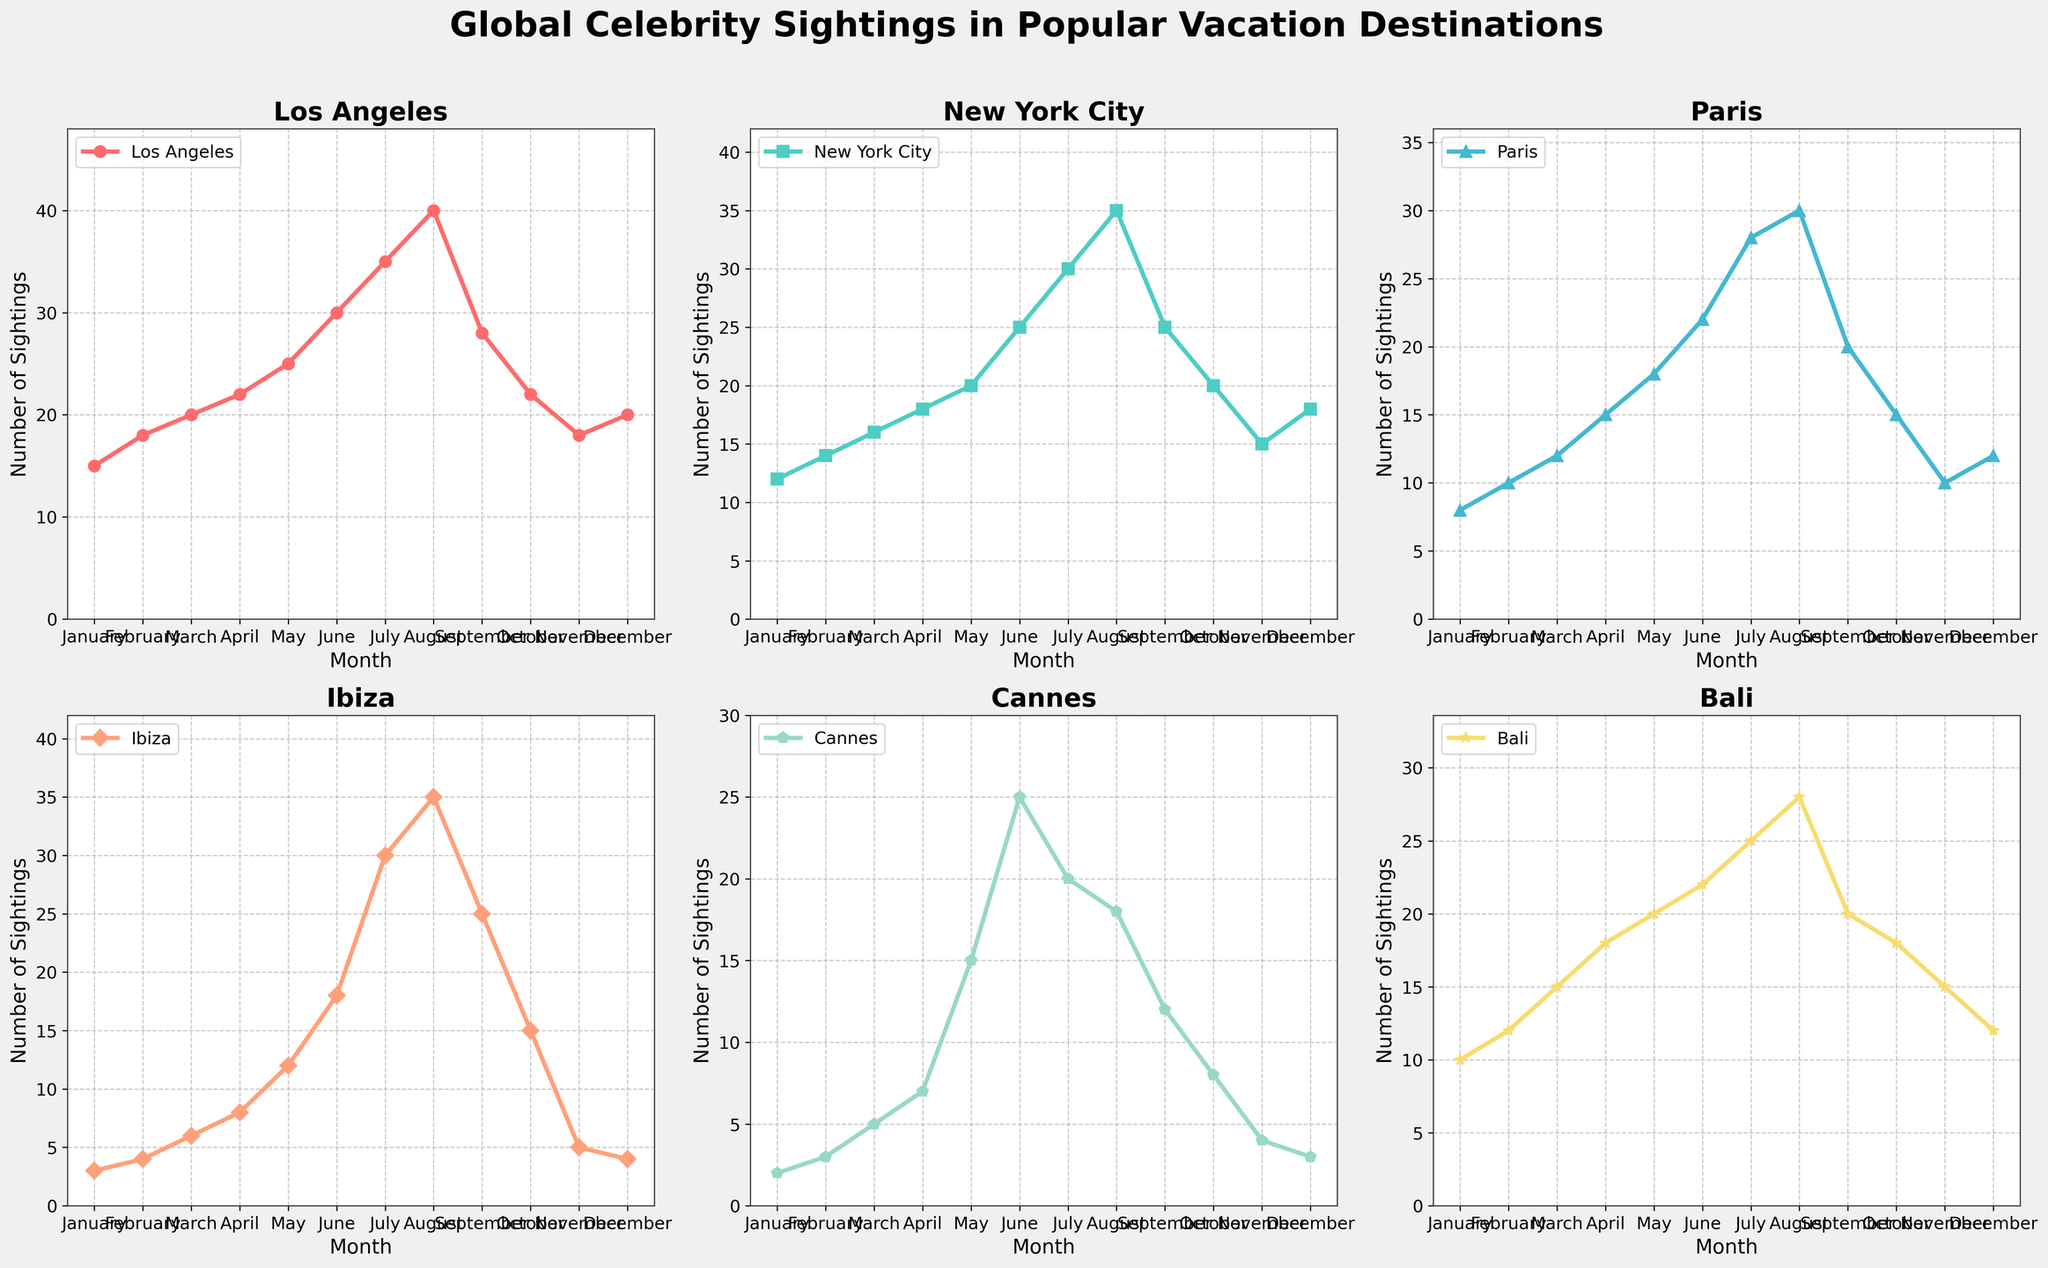What is the title of the figure? The title is located at the top of the figure and is clearly stated.
Answer: Global Celebrity Sightings in Popular Vacation Destinations In which month does Los Angeles have the highest number of celebrity sightings? Look for the peak point on the Los Angeles line chart.
Answer: August How many sightings were there in New York City in June? Check the value for June on the New York City line chart.
Answer: 25 Which location has the lowest number of sightings in January? Compare the lowest points for all locations in January.
Answer: Cannes What is the difference in the number of sightings between Paris and Ibiza in March? Subtract the number of sightings in Ibiza from the number in Paris for March.
Answer: 6 Which three locations show an increase in sightings from July to August? Identify which lines have an upward slope from July to August.
Answer: Los Angeles, New York City, Bali By how much did the number of sightings in Cannes increase from April to May? Subtract the number of sightings in April from that in May for Cannes.
Answer: 8 In which month does Bali have the second highest number of sightings? Order the numbers of sightings per month in descending order and identify the second highest.
Answer: August Which location experiences the greatest fluctuation in sightings throughout the year? Look at the range of values (difference between highest and lowest) for each location.
Answer: Los Angeles How does the number of sightings in Ibiza change from May to October? Observe the general trend of the line for Ibiza between these months.
Answer: Decreases 